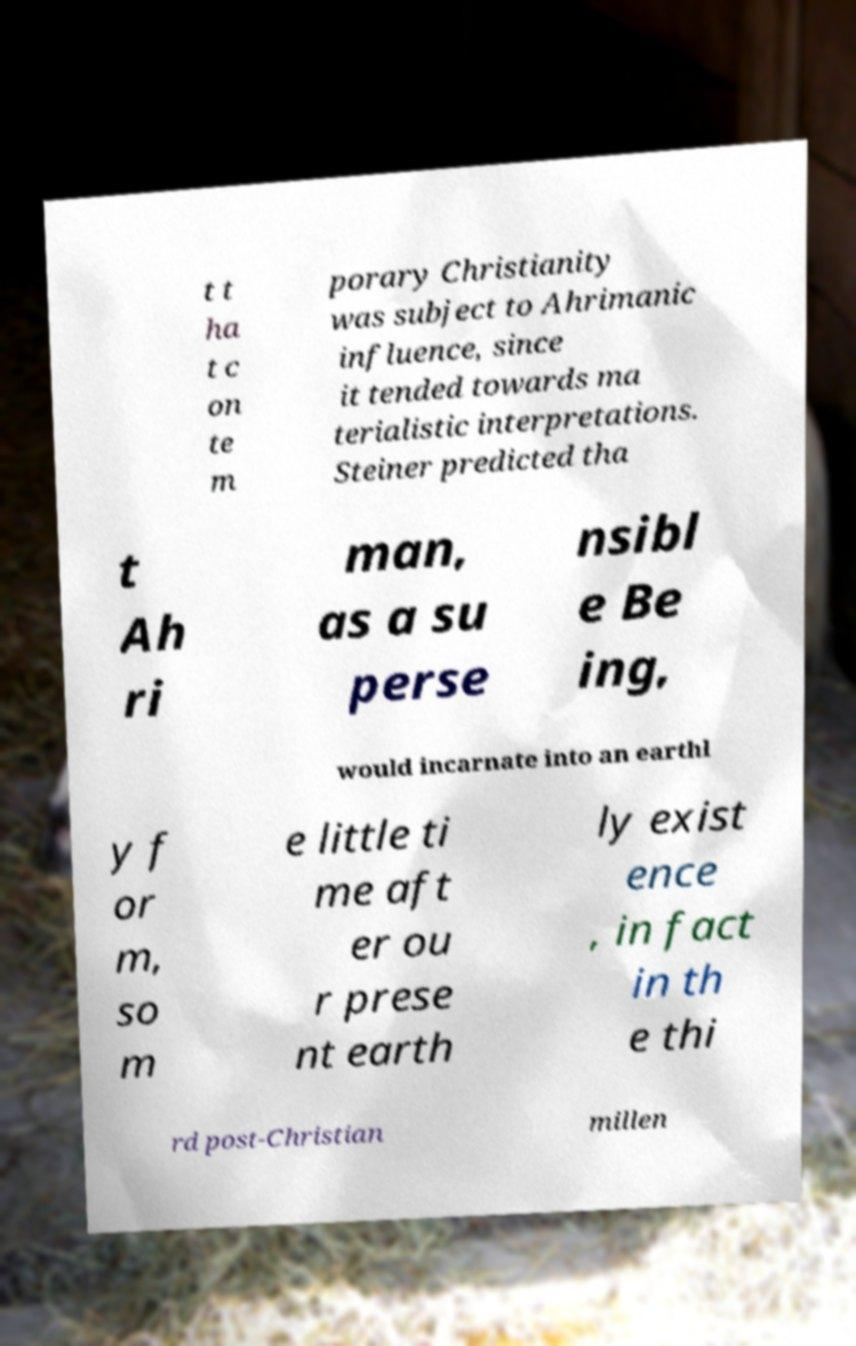Please read and relay the text visible in this image. What does it say? t t ha t c on te m porary Christianity was subject to Ahrimanic influence, since it tended towards ma terialistic interpretations. Steiner predicted tha t Ah ri man, as a su perse nsibl e Be ing, would incarnate into an earthl y f or m, so m e little ti me aft er ou r prese nt earth ly exist ence , in fact in th e thi rd post-Christian millen 